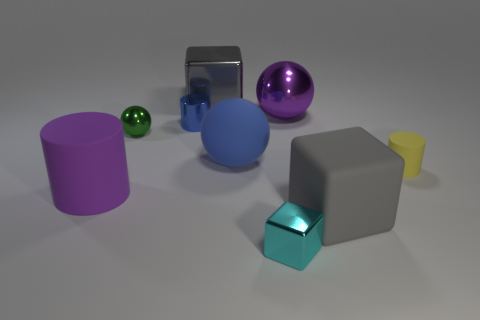How does the lighting in the scene affect the appearance of the objects? The lighting in the scene is casting gentle shadows and giving the objects a soft appearance. It highlights the reflective properties of the metallic cube and the shiny balls, while also subtly showing the textures of the matte surfaces on the rubber and plastic objects. 